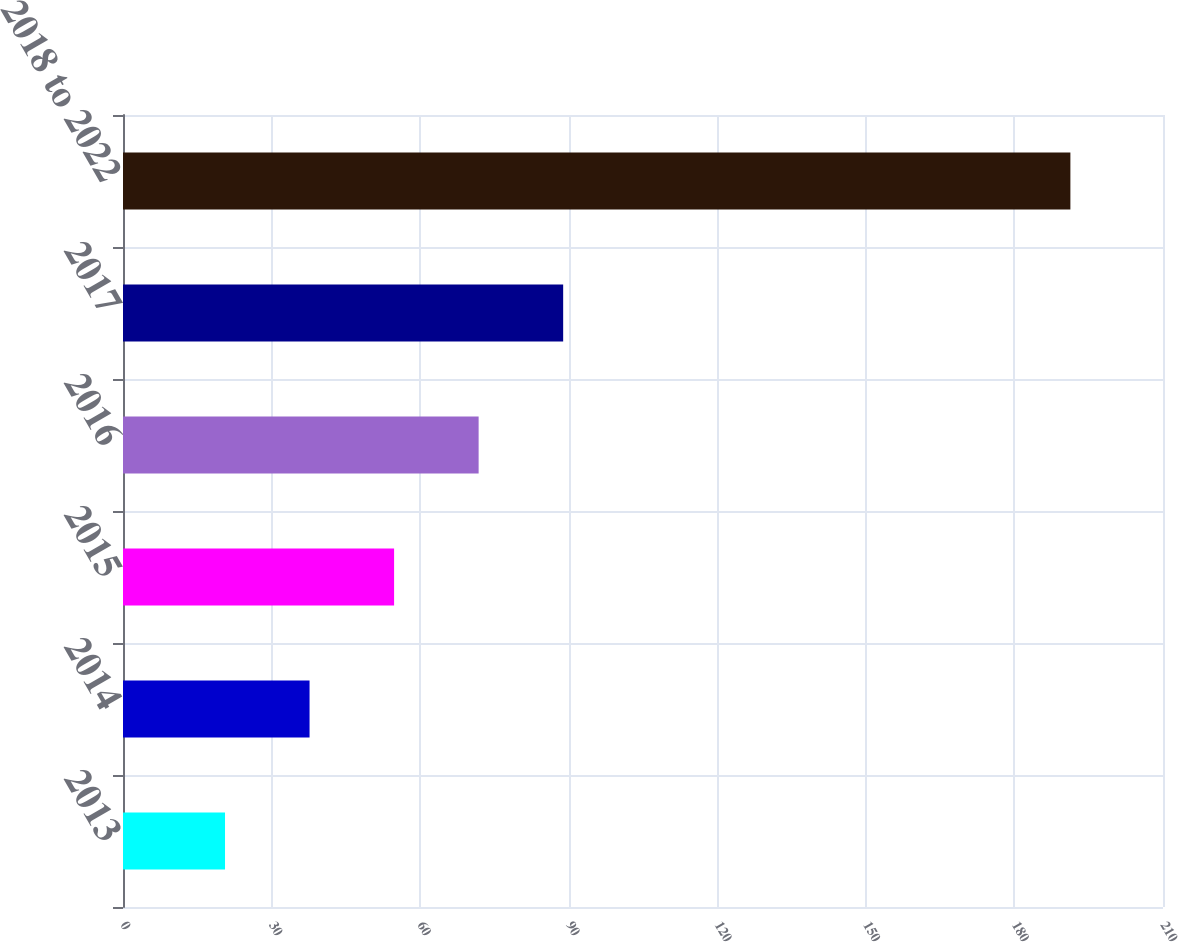<chart> <loc_0><loc_0><loc_500><loc_500><bar_chart><fcel>2013<fcel>2014<fcel>2015<fcel>2016<fcel>2017<fcel>2018 to 2022<nl><fcel>20.6<fcel>37.67<fcel>54.74<fcel>71.81<fcel>88.88<fcel>191.3<nl></chart> 